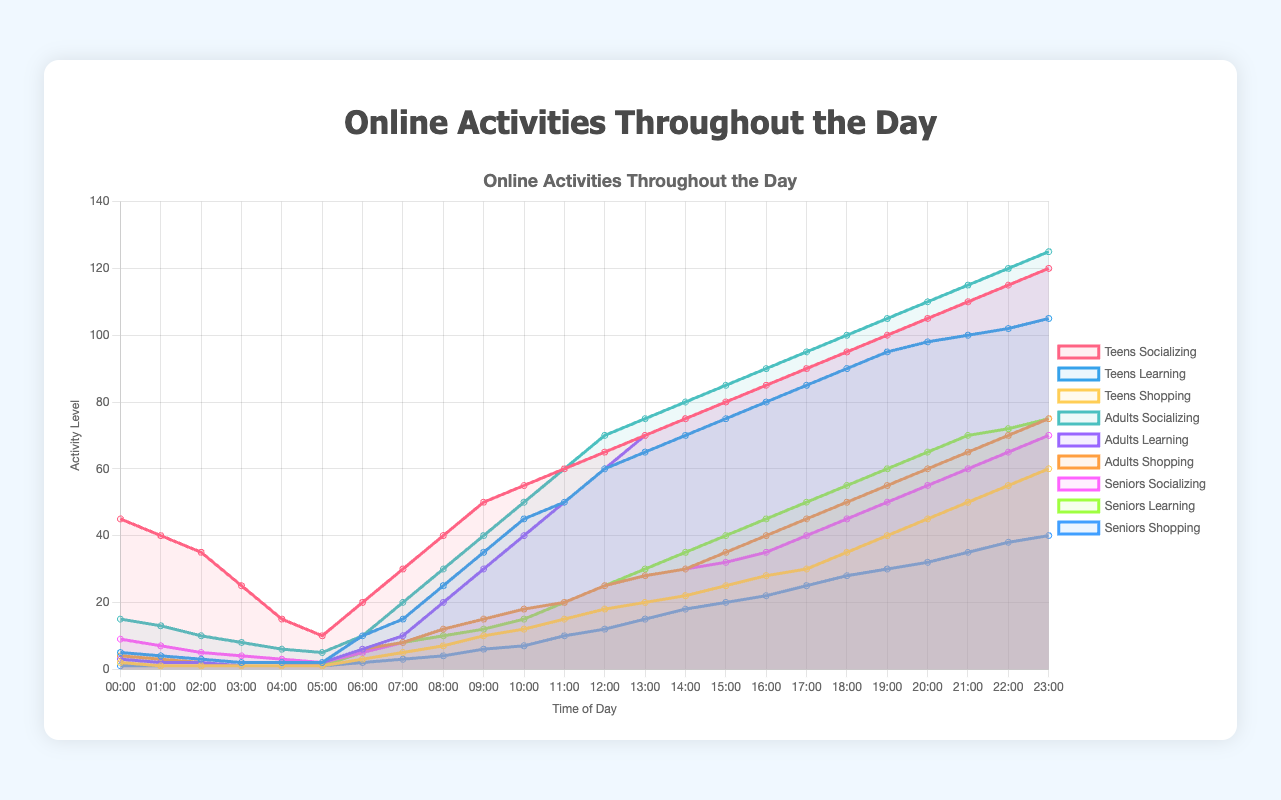What's the peak time for teens socializing? The peak time for teens socializing can be identified by looking for the highest point on the "Teens Socializing" line in the plot. The highest value is 120, and this occurs at 23:00.
Answer: 23:00 What is the difference in adults' level of socializing and shopping at 18:00? To determine the difference, look at the values for adults' socializing and shopping at 18:00. Adults socializing is 100 and adults shopping is 50. The difference is 100 - 50 = 50.
Answer: 50 Which group has the highest level of online learning at 09:00? Compare the online learning values at 09:00 for all the demographics. Teens have 35, adults have 30, and seniors have 12. Therefore, teens have the highest level of online learning at this time.
Answer: Teens What is the total activity level (socializing + learning + shopping) for seniors at 20:00? Add the values of socializing, learning, and shopping for seniors at 20:00. Socializing is 55, learning is 65, and shopping is 32. The total activity level is 55 + 65 + 32 = 152.
Answer: 152 During which time slot do adults have the lowest level of socializing? Identify the time slot with the lowest point on the "Adults Socializing" line. The lowest value of 5 occurs at 05:00.
Answer: 05:00 How many hours do teens spend more on learning than shopping in a day? To find the hours, compare the values of teens learning and shopping for each hour and count the number of hours when learning is higher than shopping. This occurs from 06:00 to 23:00.
Answer: 18 hours Which time slot shows an equal activity level for learning and socializing for seniors? Look for the time slot where the "Seniors Learning" line intersects or matches the "Seniors Socializing" line. This happens at 13:00 and 14:00 where both values are 30.
Answer: 13:00, 14:00 What is the average shopping activity level for adults between 16:00 and 18:00? Add the shopping values for adults at 16:00 (40), 17:00 (45), and 18:00 (50), then divide by 3 to find the average. (40 + 45 + 50) / 3 = 135 / 3 = 45.
Answer: 45 By how much does the socializing activity level for seniors increase from 00:00 to 23:00? Subtract the socializing value at 00:00 (9) from the value at 23:00 (70). The increase is 70 - 9 = 61.
Answer: 61 